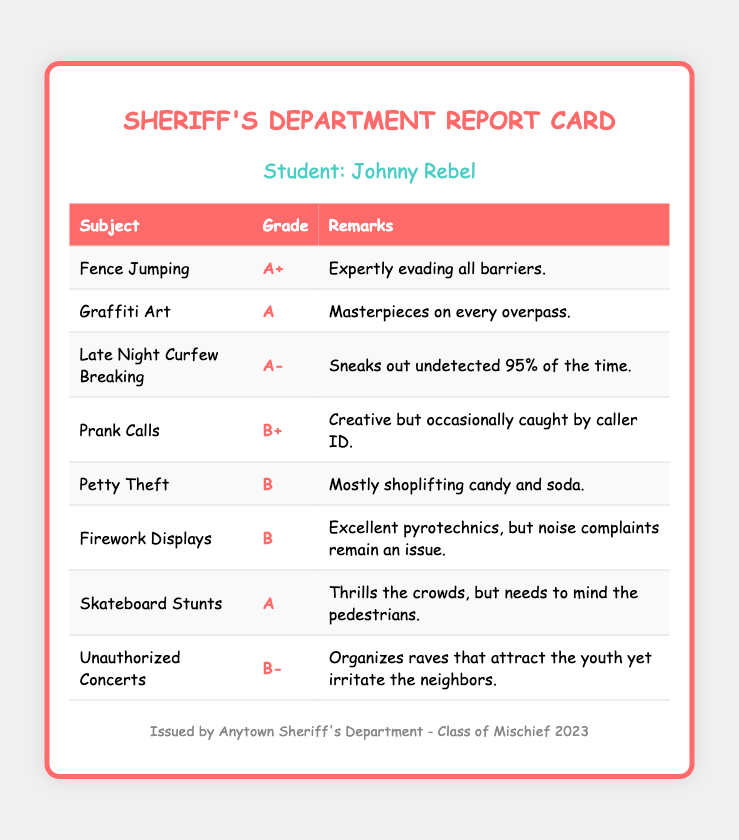what is the student’s name? The student’s name is listed at the top of the report card.
Answer: Johnny Rebel how many subjects are listed in the report card? The number of subjects is determined by counting the rows in the table (excluding the header).
Answer: 8 what grade did Johnny receive in Fence Jumping? The grade for Fence Jumping is recorded in the respective row of the table.
Answer: A+ what is the remark for Late Night Curfew Breaking? The remark can be found next to the Late Night Curfew Breaking grade.
Answer: Sneaks out undetected 95% of the time which subject received a grade of B-? The subject with a grade of B- can be found in the grade column of the table.
Answer: Unauthorized Concerts what subject did Johnny Rebel excel in the most? The subject with the highest grade indicates the area of most excellence.
Answer: Fence Jumping how did the sheriff's department describe Johnny's Graffiti Art skills? The description can be found in the remarks column next to the Graffiti Art grade.
Answer: Masterpieces on every overpass which subject listed involves using fireworks? The subject related to fireworks is specified in the table.
Answer: Firework Displays what year is this report card from? The issuing year is noted in the footer of the document.
Answer: 2023 